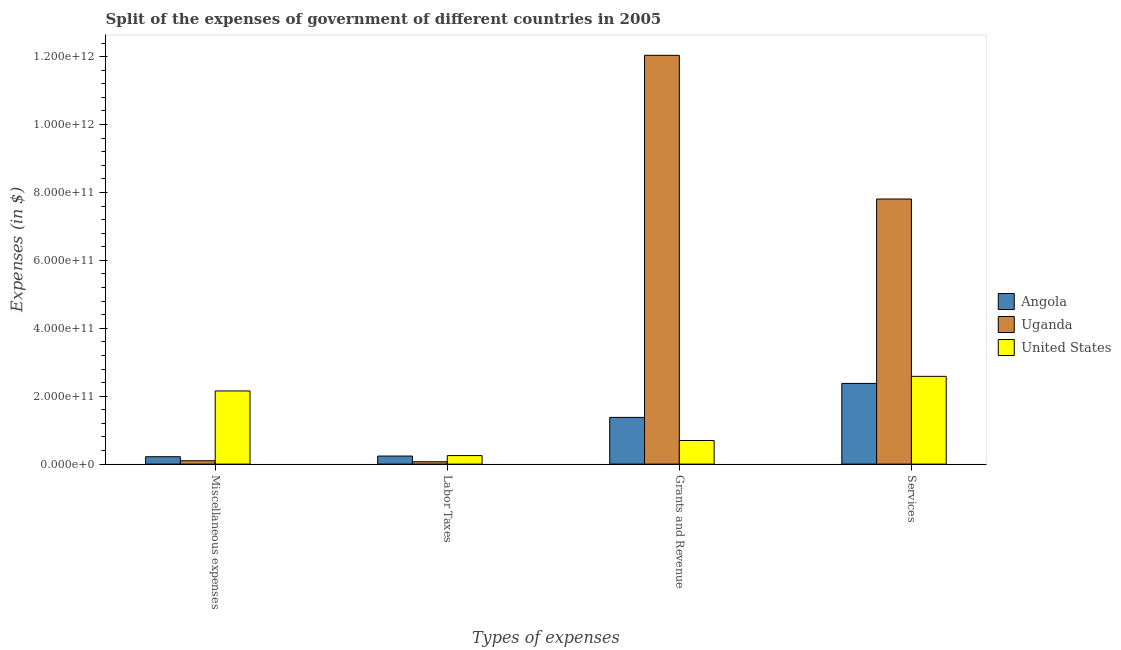Are the number of bars per tick equal to the number of legend labels?
Your response must be concise. Yes. Are the number of bars on each tick of the X-axis equal?
Make the answer very short. Yes. How many bars are there on the 3rd tick from the left?
Your response must be concise. 3. What is the label of the 1st group of bars from the left?
Provide a succinct answer. Miscellaneous expenses. What is the amount spent on grants and revenue in Angola?
Your answer should be compact. 1.38e+11. Across all countries, what is the maximum amount spent on labor taxes?
Your answer should be very brief. 2.51e+1. Across all countries, what is the minimum amount spent on miscellaneous expenses?
Your response must be concise. 9.89e+09. In which country was the amount spent on grants and revenue maximum?
Offer a terse response. Uganda. In which country was the amount spent on miscellaneous expenses minimum?
Ensure brevity in your answer.  Uganda. What is the total amount spent on services in the graph?
Keep it short and to the point. 1.28e+12. What is the difference between the amount spent on services in Angola and that in Uganda?
Provide a short and direct response. -5.43e+11. What is the difference between the amount spent on labor taxes in Angola and the amount spent on grants and revenue in Uganda?
Make the answer very short. -1.18e+12. What is the average amount spent on miscellaneous expenses per country?
Your answer should be very brief. 8.24e+1. What is the difference between the amount spent on labor taxes and amount spent on services in Uganda?
Give a very brief answer. -7.74e+11. In how many countries, is the amount spent on miscellaneous expenses greater than 880000000000 $?
Give a very brief answer. 0. What is the ratio of the amount spent on grants and revenue in United States to that in Uganda?
Offer a terse response. 0.06. Is the amount spent on grants and revenue in Uganda less than that in Angola?
Give a very brief answer. No. What is the difference between the highest and the second highest amount spent on grants and revenue?
Your answer should be compact. 1.07e+12. What is the difference between the highest and the lowest amount spent on services?
Your answer should be compact. 5.43e+11. Is the sum of the amount spent on services in United States and Uganda greater than the maximum amount spent on labor taxes across all countries?
Keep it short and to the point. Yes. What does the 3rd bar from the left in Miscellaneous expenses represents?
Keep it short and to the point. United States. What does the 1st bar from the right in Labor Taxes represents?
Ensure brevity in your answer.  United States. How many bars are there?
Provide a succinct answer. 12. How many countries are there in the graph?
Make the answer very short. 3. What is the difference between two consecutive major ticks on the Y-axis?
Provide a short and direct response. 2.00e+11. How many legend labels are there?
Provide a short and direct response. 3. How are the legend labels stacked?
Provide a succinct answer. Vertical. What is the title of the graph?
Offer a terse response. Split of the expenses of government of different countries in 2005. What is the label or title of the X-axis?
Give a very brief answer. Types of expenses. What is the label or title of the Y-axis?
Give a very brief answer. Expenses (in $). What is the Expenses (in $) in Angola in Miscellaneous expenses?
Your answer should be very brief. 2.17e+1. What is the Expenses (in $) of Uganda in Miscellaneous expenses?
Offer a very short reply. 9.89e+09. What is the Expenses (in $) in United States in Miscellaneous expenses?
Ensure brevity in your answer.  2.16e+11. What is the Expenses (in $) of Angola in Labor Taxes?
Provide a short and direct response. 2.37e+1. What is the Expenses (in $) of Uganda in Labor Taxes?
Make the answer very short. 6.95e+09. What is the Expenses (in $) of United States in Labor Taxes?
Give a very brief answer. 2.51e+1. What is the Expenses (in $) in Angola in Grants and Revenue?
Keep it short and to the point. 1.38e+11. What is the Expenses (in $) in Uganda in Grants and Revenue?
Your answer should be very brief. 1.20e+12. What is the Expenses (in $) of United States in Grants and Revenue?
Keep it short and to the point. 6.95e+1. What is the Expenses (in $) of Angola in Services?
Provide a short and direct response. 2.38e+11. What is the Expenses (in $) of Uganda in Services?
Provide a short and direct response. 7.81e+11. What is the Expenses (in $) of United States in Services?
Your response must be concise. 2.58e+11. Across all Types of expenses, what is the maximum Expenses (in $) in Angola?
Offer a terse response. 2.38e+11. Across all Types of expenses, what is the maximum Expenses (in $) of Uganda?
Ensure brevity in your answer.  1.20e+12. Across all Types of expenses, what is the maximum Expenses (in $) of United States?
Your answer should be very brief. 2.58e+11. Across all Types of expenses, what is the minimum Expenses (in $) in Angola?
Your answer should be very brief. 2.17e+1. Across all Types of expenses, what is the minimum Expenses (in $) in Uganda?
Offer a terse response. 6.95e+09. Across all Types of expenses, what is the minimum Expenses (in $) of United States?
Offer a very short reply. 2.51e+1. What is the total Expenses (in $) of Angola in the graph?
Give a very brief answer. 4.21e+11. What is the total Expenses (in $) in Uganda in the graph?
Give a very brief answer. 2.00e+12. What is the total Expenses (in $) of United States in the graph?
Keep it short and to the point. 5.69e+11. What is the difference between the Expenses (in $) of Angola in Miscellaneous expenses and that in Labor Taxes?
Offer a very short reply. -1.98e+09. What is the difference between the Expenses (in $) of Uganda in Miscellaneous expenses and that in Labor Taxes?
Offer a terse response. 2.94e+09. What is the difference between the Expenses (in $) in United States in Miscellaneous expenses and that in Labor Taxes?
Your answer should be compact. 1.90e+11. What is the difference between the Expenses (in $) of Angola in Miscellaneous expenses and that in Grants and Revenue?
Keep it short and to the point. -1.16e+11. What is the difference between the Expenses (in $) in Uganda in Miscellaneous expenses and that in Grants and Revenue?
Provide a short and direct response. -1.19e+12. What is the difference between the Expenses (in $) in United States in Miscellaneous expenses and that in Grants and Revenue?
Offer a very short reply. 1.46e+11. What is the difference between the Expenses (in $) of Angola in Miscellaneous expenses and that in Services?
Ensure brevity in your answer.  -2.16e+11. What is the difference between the Expenses (in $) of Uganda in Miscellaneous expenses and that in Services?
Keep it short and to the point. -7.71e+11. What is the difference between the Expenses (in $) in United States in Miscellaneous expenses and that in Services?
Offer a terse response. -4.30e+1. What is the difference between the Expenses (in $) in Angola in Labor Taxes and that in Grants and Revenue?
Make the answer very short. -1.14e+11. What is the difference between the Expenses (in $) of Uganda in Labor Taxes and that in Grants and Revenue?
Offer a very short reply. -1.20e+12. What is the difference between the Expenses (in $) of United States in Labor Taxes and that in Grants and Revenue?
Provide a short and direct response. -4.44e+1. What is the difference between the Expenses (in $) of Angola in Labor Taxes and that in Services?
Keep it short and to the point. -2.14e+11. What is the difference between the Expenses (in $) in Uganda in Labor Taxes and that in Services?
Provide a succinct answer. -7.74e+11. What is the difference between the Expenses (in $) in United States in Labor Taxes and that in Services?
Offer a terse response. -2.33e+11. What is the difference between the Expenses (in $) of Angola in Grants and Revenue and that in Services?
Your answer should be compact. -1.00e+11. What is the difference between the Expenses (in $) of Uganda in Grants and Revenue and that in Services?
Ensure brevity in your answer.  4.23e+11. What is the difference between the Expenses (in $) of United States in Grants and Revenue and that in Services?
Provide a succinct answer. -1.89e+11. What is the difference between the Expenses (in $) of Angola in Miscellaneous expenses and the Expenses (in $) of Uganda in Labor Taxes?
Provide a short and direct response. 1.48e+1. What is the difference between the Expenses (in $) of Angola in Miscellaneous expenses and the Expenses (in $) of United States in Labor Taxes?
Make the answer very short. -3.36e+09. What is the difference between the Expenses (in $) in Uganda in Miscellaneous expenses and the Expenses (in $) in United States in Labor Taxes?
Provide a short and direct response. -1.52e+1. What is the difference between the Expenses (in $) of Angola in Miscellaneous expenses and the Expenses (in $) of Uganda in Grants and Revenue?
Your response must be concise. -1.18e+12. What is the difference between the Expenses (in $) of Angola in Miscellaneous expenses and the Expenses (in $) of United States in Grants and Revenue?
Your answer should be very brief. -4.78e+1. What is the difference between the Expenses (in $) of Uganda in Miscellaneous expenses and the Expenses (in $) of United States in Grants and Revenue?
Your response must be concise. -5.96e+1. What is the difference between the Expenses (in $) of Angola in Miscellaneous expenses and the Expenses (in $) of Uganda in Services?
Offer a terse response. -7.59e+11. What is the difference between the Expenses (in $) of Angola in Miscellaneous expenses and the Expenses (in $) of United States in Services?
Ensure brevity in your answer.  -2.37e+11. What is the difference between the Expenses (in $) in Uganda in Miscellaneous expenses and the Expenses (in $) in United States in Services?
Your response must be concise. -2.49e+11. What is the difference between the Expenses (in $) of Angola in Labor Taxes and the Expenses (in $) of Uganda in Grants and Revenue?
Offer a very short reply. -1.18e+12. What is the difference between the Expenses (in $) in Angola in Labor Taxes and the Expenses (in $) in United States in Grants and Revenue?
Your response must be concise. -4.58e+1. What is the difference between the Expenses (in $) in Uganda in Labor Taxes and the Expenses (in $) in United States in Grants and Revenue?
Your answer should be compact. -6.26e+1. What is the difference between the Expenses (in $) in Angola in Labor Taxes and the Expenses (in $) in Uganda in Services?
Offer a terse response. -7.57e+11. What is the difference between the Expenses (in $) in Angola in Labor Taxes and the Expenses (in $) in United States in Services?
Your response must be concise. -2.35e+11. What is the difference between the Expenses (in $) of Uganda in Labor Taxes and the Expenses (in $) of United States in Services?
Ensure brevity in your answer.  -2.52e+11. What is the difference between the Expenses (in $) of Angola in Grants and Revenue and the Expenses (in $) of Uganda in Services?
Provide a short and direct response. -6.43e+11. What is the difference between the Expenses (in $) of Angola in Grants and Revenue and the Expenses (in $) of United States in Services?
Your answer should be very brief. -1.21e+11. What is the difference between the Expenses (in $) in Uganda in Grants and Revenue and the Expenses (in $) in United States in Services?
Ensure brevity in your answer.  9.45e+11. What is the average Expenses (in $) of Angola per Types of expenses?
Provide a succinct answer. 1.05e+11. What is the average Expenses (in $) in Uganda per Types of expenses?
Offer a very short reply. 5.00e+11. What is the average Expenses (in $) of United States per Types of expenses?
Ensure brevity in your answer.  1.42e+11. What is the difference between the Expenses (in $) of Angola and Expenses (in $) of Uganda in Miscellaneous expenses?
Make the answer very short. 1.19e+1. What is the difference between the Expenses (in $) in Angola and Expenses (in $) in United States in Miscellaneous expenses?
Offer a terse response. -1.94e+11. What is the difference between the Expenses (in $) of Uganda and Expenses (in $) of United States in Miscellaneous expenses?
Keep it short and to the point. -2.06e+11. What is the difference between the Expenses (in $) of Angola and Expenses (in $) of Uganda in Labor Taxes?
Provide a succinct answer. 1.68e+1. What is the difference between the Expenses (in $) in Angola and Expenses (in $) in United States in Labor Taxes?
Ensure brevity in your answer.  -1.38e+09. What is the difference between the Expenses (in $) in Uganda and Expenses (in $) in United States in Labor Taxes?
Offer a terse response. -1.82e+1. What is the difference between the Expenses (in $) of Angola and Expenses (in $) of Uganda in Grants and Revenue?
Offer a very short reply. -1.07e+12. What is the difference between the Expenses (in $) of Angola and Expenses (in $) of United States in Grants and Revenue?
Give a very brief answer. 6.81e+1. What is the difference between the Expenses (in $) in Uganda and Expenses (in $) in United States in Grants and Revenue?
Provide a succinct answer. 1.13e+12. What is the difference between the Expenses (in $) in Angola and Expenses (in $) in Uganda in Services?
Make the answer very short. -5.43e+11. What is the difference between the Expenses (in $) of Angola and Expenses (in $) of United States in Services?
Provide a short and direct response. -2.09e+1. What is the difference between the Expenses (in $) of Uganda and Expenses (in $) of United States in Services?
Keep it short and to the point. 5.22e+11. What is the ratio of the Expenses (in $) in Angola in Miscellaneous expenses to that in Labor Taxes?
Offer a very short reply. 0.92. What is the ratio of the Expenses (in $) in Uganda in Miscellaneous expenses to that in Labor Taxes?
Ensure brevity in your answer.  1.42. What is the ratio of the Expenses (in $) of United States in Miscellaneous expenses to that in Labor Taxes?
Give a very brief answer. 8.59. What is the ratio of the Expenses (in $) in Angola in Miscellaneous expenses to that in Grants and Revenue?
Offer a very short reply. 0.16. What is the ratio of the Expenses (in $) in Uganda in Miscellaneous expenses to that in Grants and Revenue?
Offer a very short reply. 0.01. What is the ratio of the Expenses (in $) of United States in Miscellaneous expenses to that in Grants and Revenue?
Make the answer very short. 3.1. What is the ratio of the Expenses (in $) of Angola in Miscellaneous expenses to that in Services?
Provide a short and direct response. 0.09. What is the ratio of the Expenses (in $) in Uganda in Miscellaneous expenses to that in Services?
Provide a short and direct response. 0.01. What is the ratio of the Expenses (in $) in United States in Miscellaneous expenses to that in Services?
Your response must be concise. 0.83. What is the ratio of the Expenses (in $) of Angola in Labor Taxes to that in Grants and Revenue?
Make the answer very short. 0.17. What is the ratio of the Expenses (in $) of Uganda in Labor Taxes to that in Grants and Revenue?
Give a very brief answer. 0.01. What is the ratio of the Expenses (in $) of United States in Labor Taxes to that in Grants and Revenue?
Your response must be concise. 0.36. What is the ratio of the Expenses (in $) in Angola in Labor Taxes to that in Services?
Your answer should be compact. 0.1. What is the ratio of the Expenses (in $) in Uganda in Labor Taxes to that in Services?
Make the answer very short. 0.01. What is the ratio of the Expenses (in $) of United States in Labor Taxes to that in Services?
Provide a short and direct response. 0.1. What is the ratio of the Expenses (in $) in Angola in Grants and Revenue to that in Services?
Offer a very short reply. 0.58. What is the ratio of the Expenses (in $) of Uganda in Grants and Revenue to that in Services?
Provide a short and direct response. 1.54. What is the ratio of the Expenses (in $) of United States in Grants and Revenue to that in Services?
Make the answer very short. 0.27. What is the difference between the highest and the second highest Expenses (in $) of Angola?
Give a very brief answer. 1.00e+11. What is the difference between the highest and the second highest Expenses (in $) of Uganda?
Make the answer very short. 4.23e+11. What is the difference between the highest and the second highest Expenses (in $) in United States?
Make the answer very short. 4.30e+1. What is the difference between the highest and the lowest Expenses (in $) in Angola?
Provide a succinct answer. 2.16e+11. What is the difference between the highest and the lowest Expenses (in $) in Uganda?
Provide a short and direct response. 1.20e+12. What is the difference between the highest and the lowest Expenses (in $) in United States?
Your answer should be compact. 2.33e+11. 